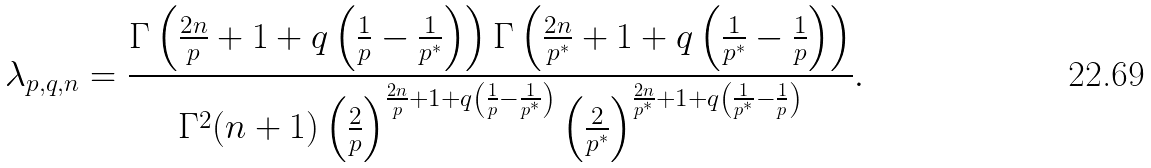Convert formula to latex. <formula><loc_0><loc_0><loc_500><loc_500>\lambda _ { p , q , n } = \frac { \Gamma \left ( \frac { 2 n } { p } + 1 + q \left ( \frac { 1 } { p } - \frac { 1 } { p ^ { * } } \right ) \right ) \Gamma \left ( \frac { 2 n } { p ^ { * } } + 1 + q \left ( \frac { 1 } { p ^ { * } } - \frac { 1 } { p } \right ) \right ) } { \Gamma ^ { 2 } ( n + 1 ) \left ( \frac { 2 } { p } \right ) ^ { \frac { 2 n } { p } + 1 + q \left ( \frac { 1 } { p } - \frac { 1 } { p ^ { * } } \right ) } \left ( \frac { 2 } { p ^ { * } } \right ) ^ { \frac { 2 n } { p ^ { * } } + 1 + q \left ( \frac { 1 } { p ^ { * } } - \frac { 1 } { p } \right ) } } .</formula> 